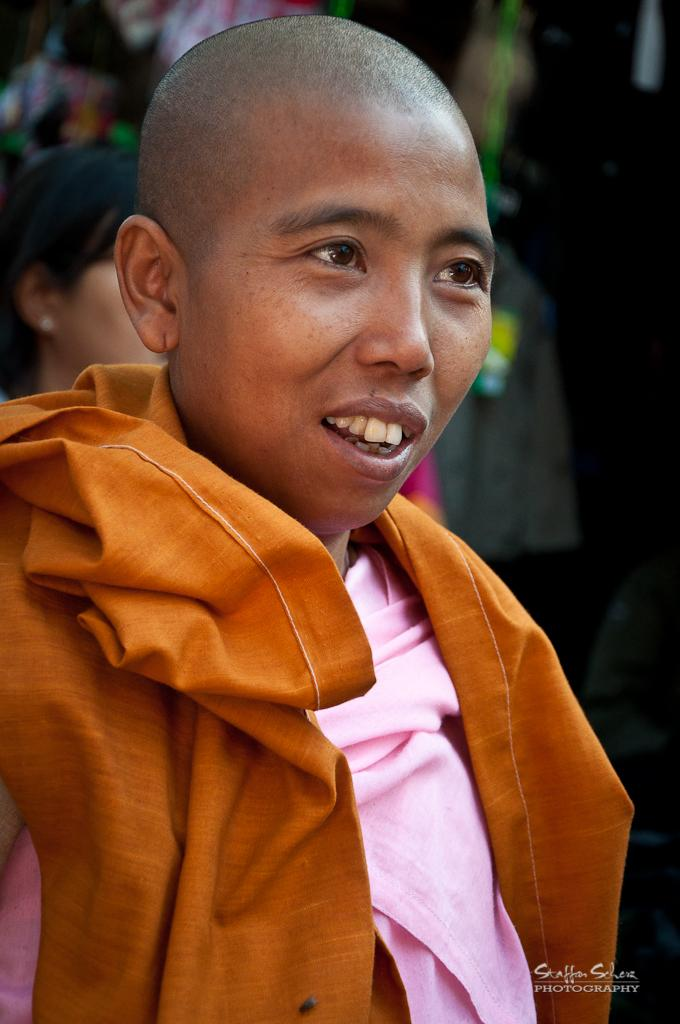What is the primary subject in the image? There is a human standing in the image. Can you describe the gender be determined for the person standing in the image? Yes, there is a woman standing behind the human. What is the person wearing in the image? The person is wearing an orange cloth. Is there any text present in the image? Yes, there is text in the bottom right corner of the image. What type of machine is being controlled by the person in the image? There is no machine present in the image, and the person is not controlling anything. 